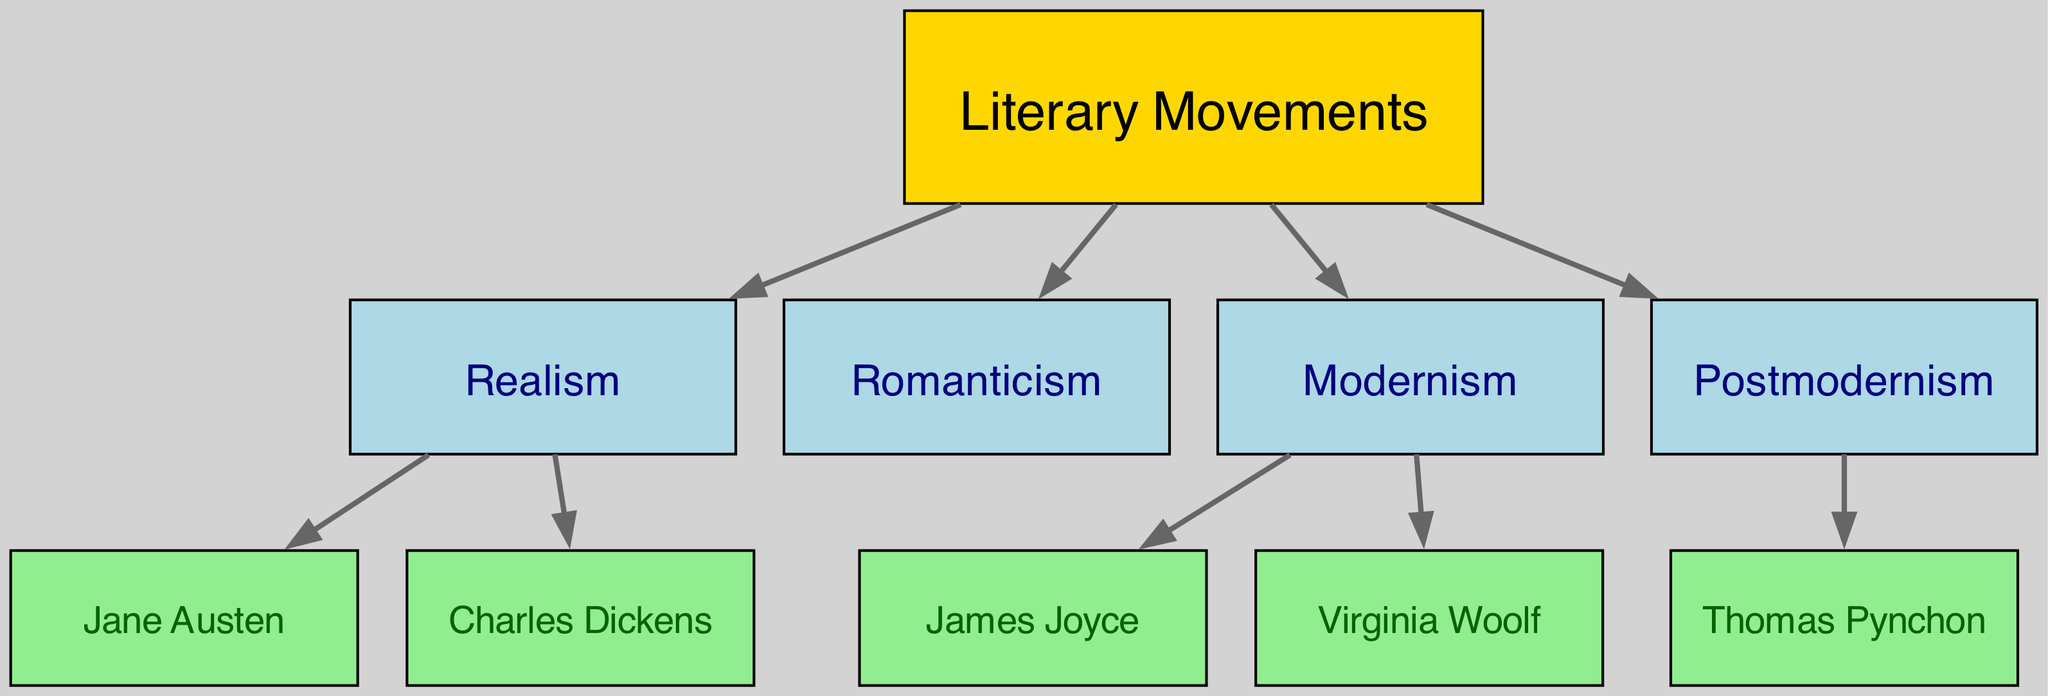What are the four primary literary movements represented in the diagram? The diagram lists four literary movements: Realism, Romanticism, Modernism, and Postmodernism. Each of these movements is a child node connected to the root node "Literary Movements."
Answer: Realism, Romanticism, Modernism, Postmodernism Which novelist is associated with Realism? The diagram shows that both Jane Austen and Charles Dickens are connected to the Realism movement, indicating they are the novelists associated with this literary style.
Answer: Jane Austen, Charles Dickens How many novelists are influenced by Modernism? The diagram illustrates that there are two novelists connected to the Modernism movement: James Joyce and Virginia Woolf. Hence, the count of novelists influenced by Modernism is two.
Answer: 2 Which literary movement does Thomas Pynchon belong to? The diagram indicates that Thomas Pynchon is linked to the Postmodernism movement, meaning he is categorized under this particular literary style.
Answer: Postmodernism Identify the nodes that are children of the “Literary Movements” node. Reviewing the diagram, the children nodes directly connected to "Literary Movements" are Realism, Romanticism, Modernism, and Postmodernism. These nodes represent the primary literary movements.
Answer: Realism, Romanticism, Modernism, Postmodernism What is the relationship between Virginia Woolf and Modernism? The diagram presents Virginia Woolf as a child node connected to the Modernism movement, indicating that she is influenced by and associates her work with this literary style.
Answer: Influenced by How many edges are present between literary movements and novelists? By analyzing the diagram, there are a total of five edges connecting the movements to their respective novelists: two for Realism, two for Modernism, and one for Postmodernism. This gives a total of five edges.
Answer: 5 Which literary movement has the most novelists connected to it? The diagram indicates that the Realism movement has two connected novelists (Jane Austen and Charles Dickens), while Modernism also has two (James Joyce and Virginia Woolf) and Postmodernism has one (Thomas Pynchon). Since Realism and Modernism share the highest count of connections, both are tied in this aspect.
Answer: Realism, Modernism 